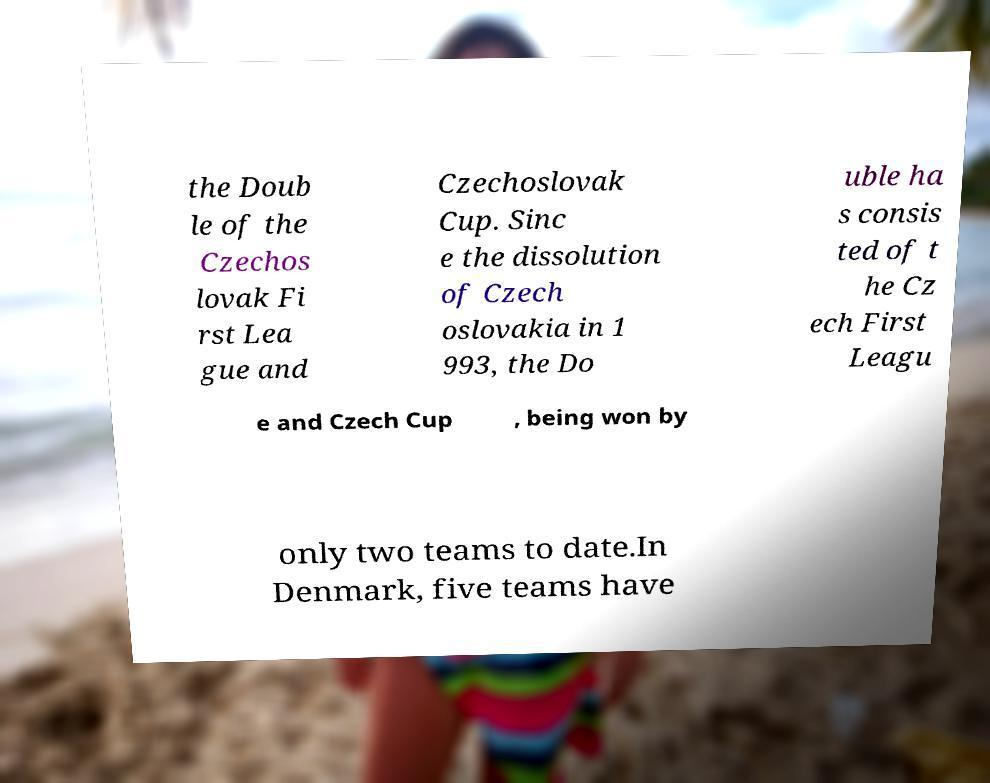What messages or text are displayed in this image? I need them in a readable, typed format. the Doub le of the Czechos lovak Fi rst Lea gue and Czechoslovak Cup. Sinc e the dissolution of Czech oslovakia in 1 993, the Do uble ha s consis ted of t he Cz ech First Leagu e and Czech Cup , being won by only two teams to date.In Denmark, five teams have 